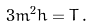Convert formula to latex. <formula><loc_0><loc_0><loc_500><loc_500>3 m ^ { 2 } h = T \, .</formula> 